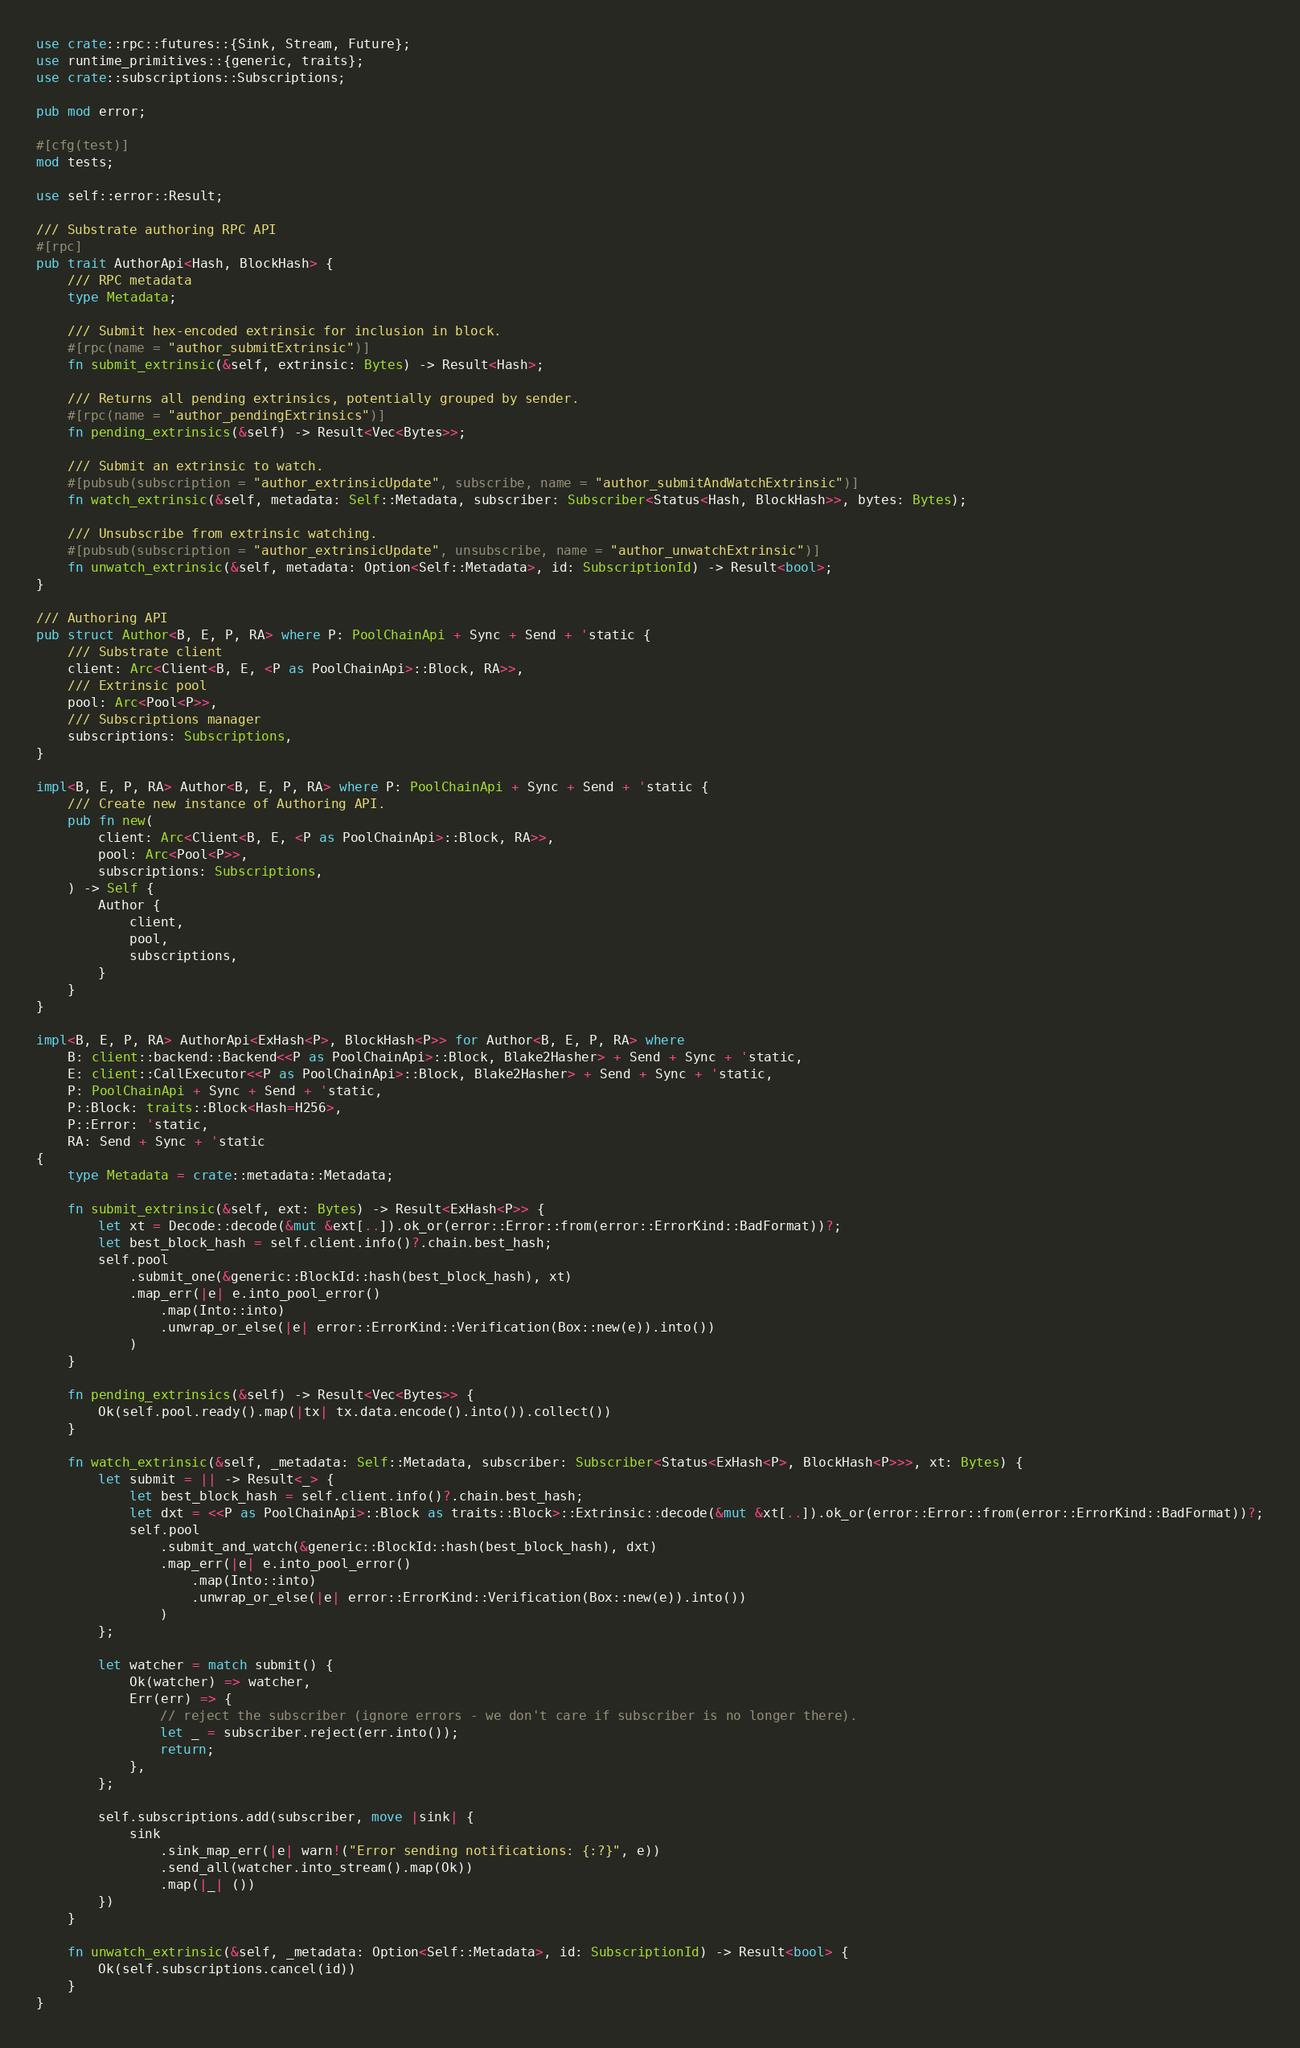<code> <loc_0><loc_0><loc_500><loc_500><_Rust_>use crate::rpc::futures::{Sink, Stream, Future};
use runtime_primitives::{generic, traits};
use crate::subscriptions::Subscriptions;

pub mod error;

#[cfg(test)]
mod tests;

use self::error::Result;

/// Substrate authoring RPC API
#[rpc]
pub trait AuthorApi<Hash, BlockHash> {
	/// RPC metadata
	type Metadata;

	/// Submit hex-encoded extrinsic for inclusion in block.
	#[rpc(name = "author_submitExtrinsic")]
	fn submit_extrinsic(&self, extrinsic: Bytes) -> Result<Hash>;

	/// Returns all pending extrinsics, potentially grouped by sender.
	#[rpc(name = "author_pendingExtrinsics")]
	fn pending_extrinsics(&self) -> Result<Vec<Bytes>>;

	/// Submit an extrinsic to watch.
	#[pubsub(subscription = "author_extrinsicUpdate", subscribe, name = "author_submitAndWatchExtrinsic")]
	fn watch_extrinsic(&self, metadata: Self::Metadata, subscriber: Subscriber<Status<Hash, BlockHash>>, bytes: Bytes);

	/// Unsubscribe from extrinsic watching.
	#[pubsub(subscription = "author_extrinsicUpdate", unsubscribe, name = "author_unwatchExtrinsic")]
	fn unwatch_extrinsic(&self, metadata: Option<Self::Metadata>, id: SubscriptionId) -> Result<bool>;
}

/// Authoring API
pub struct Author<B, E, P, RA> where P: PoolChainApi + Sync + Send + 'static {
	/// Substrate client
	client: Arc<Client<B, E, <P as PoolChainApi>::Block, RA>>,
	/// Extrinsic pool
	pool: Arc<Pool<P>>,
	/// Subscriptions manager
	subscriptions: Subscriptions,
}

impl<B, E, P, RA> Author<B, E, P, RA> where P: PoolChainApi + Sync + Send + 'static {
	/// Create new instance of Authoring API.
	pub fn new(
		client: Arc<Client<B, E, <P as PoolChainApi>::Block, RA>>,
		pool: Arc<Pool<P>>,
		subscriptions: Subscriptions,
	) -> Self {
		Author {
			client,
			pool,
			subscriptions,
		}
	}
}

impl<B, E, P, RA> AuthorApi<ExHash<P>, BlockHash<P>> for Author<B, E, P, RA> where
	B: client::backend::Backend<<P as PoolChainApi>::Block, Blake2Hasher> + Send + Sync + 'static,
	E: client::CallExecutor<<P as PoolChainApi>::Block, Blake2Hasher> + Send + Sync + 'static,
	P: PoolChainApi + Sync + Send + 'static,
	P::Block: traits::Block<Hash=H256>,
	P::Error: 'static,
	RA: Send + Sync + 'static
{
	type Metadata = crate::metadata::Metadata;

	fn submit_extrinsic(&self, ext: Bytes) -> Result<ExHash<P>> {
		let xt = Decode::decode(&mut &ext[..]).ok_or(error::Error::from(error::ErrorKind::BadFormat))?;
		let best_block_hash = self.client.info()?.chain.best_hash;
		self.pool
			.submit_one(&generic::BlockId::hash(best_block_hash), xt)
			.map_err(|e| e.into_pool_error()
				.map(Into::into)
				.unwrap_or_else(|e| error::ErrorKind::Verification(Box::new(e)).into())
			)
	}

	fn pending_extrinsics(&self) -> Result<Vec<Bytes>> {
		Ok(self.pool.ready().map(|tx| tx.data.encode().into()).collect())
	}

	fn watch_extrinsic(&self, _metadata: Self::Metadata, subscriber: Subscriber<Status<ExHash<P>, BlockHash<P>>>, xt: Bytes) {
		let submit = || -> Result<_> {
			let best_block_hash = self.client.info()?.chain.best_hash;
			let dxt = <<P as PoolChainApi>::Block as traits::Block>::Extrinsic::decode(&mut &xt[..]).ok_or(error::Error::from(error::ErrorKind::BadFormat))?;
			self.pool
				.submit_and_watch(&generic::BlockId::hash(best_block_hash), dxt)
				.map_err(|e| e.into_pool_error()
					.map(Into::into)
					.unwrap_or_else(|e| error::ErrorKind::Verification(Box::new(e)).into())
				)
		};

		let watcher = match submit() {
			Ok(watcher) => watcher,
			Err(err) => {
				// reject the subscriber (ignore errors - we don't care if subscriber is no longer there).
				let _ = subscriber.reject(err.into());
				return;
			},
		};

		self.subscriptions.add(subscriber, move |sink| {
			sink
				.sink_map_err(|e| warn!("Error sending notifications: {:?}", e))
				.send_all(watcher.into_stream().map(Ok))
				.map(|_| ())
		})
	}

	fn unwatch_extrinsic(&self, _metadata: Option<Self::Metadata>, id: SubscriptionId) -> Result<bool> {
		Ok(self.subscriptions.cancel(id))
	}
}
</code> 